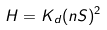Convert formula to latex. <formula><loc_0><loc_0><loc_500><loc_500>H = K _ { d } ( { n } { S } ) ^ { 2 }</formula> 